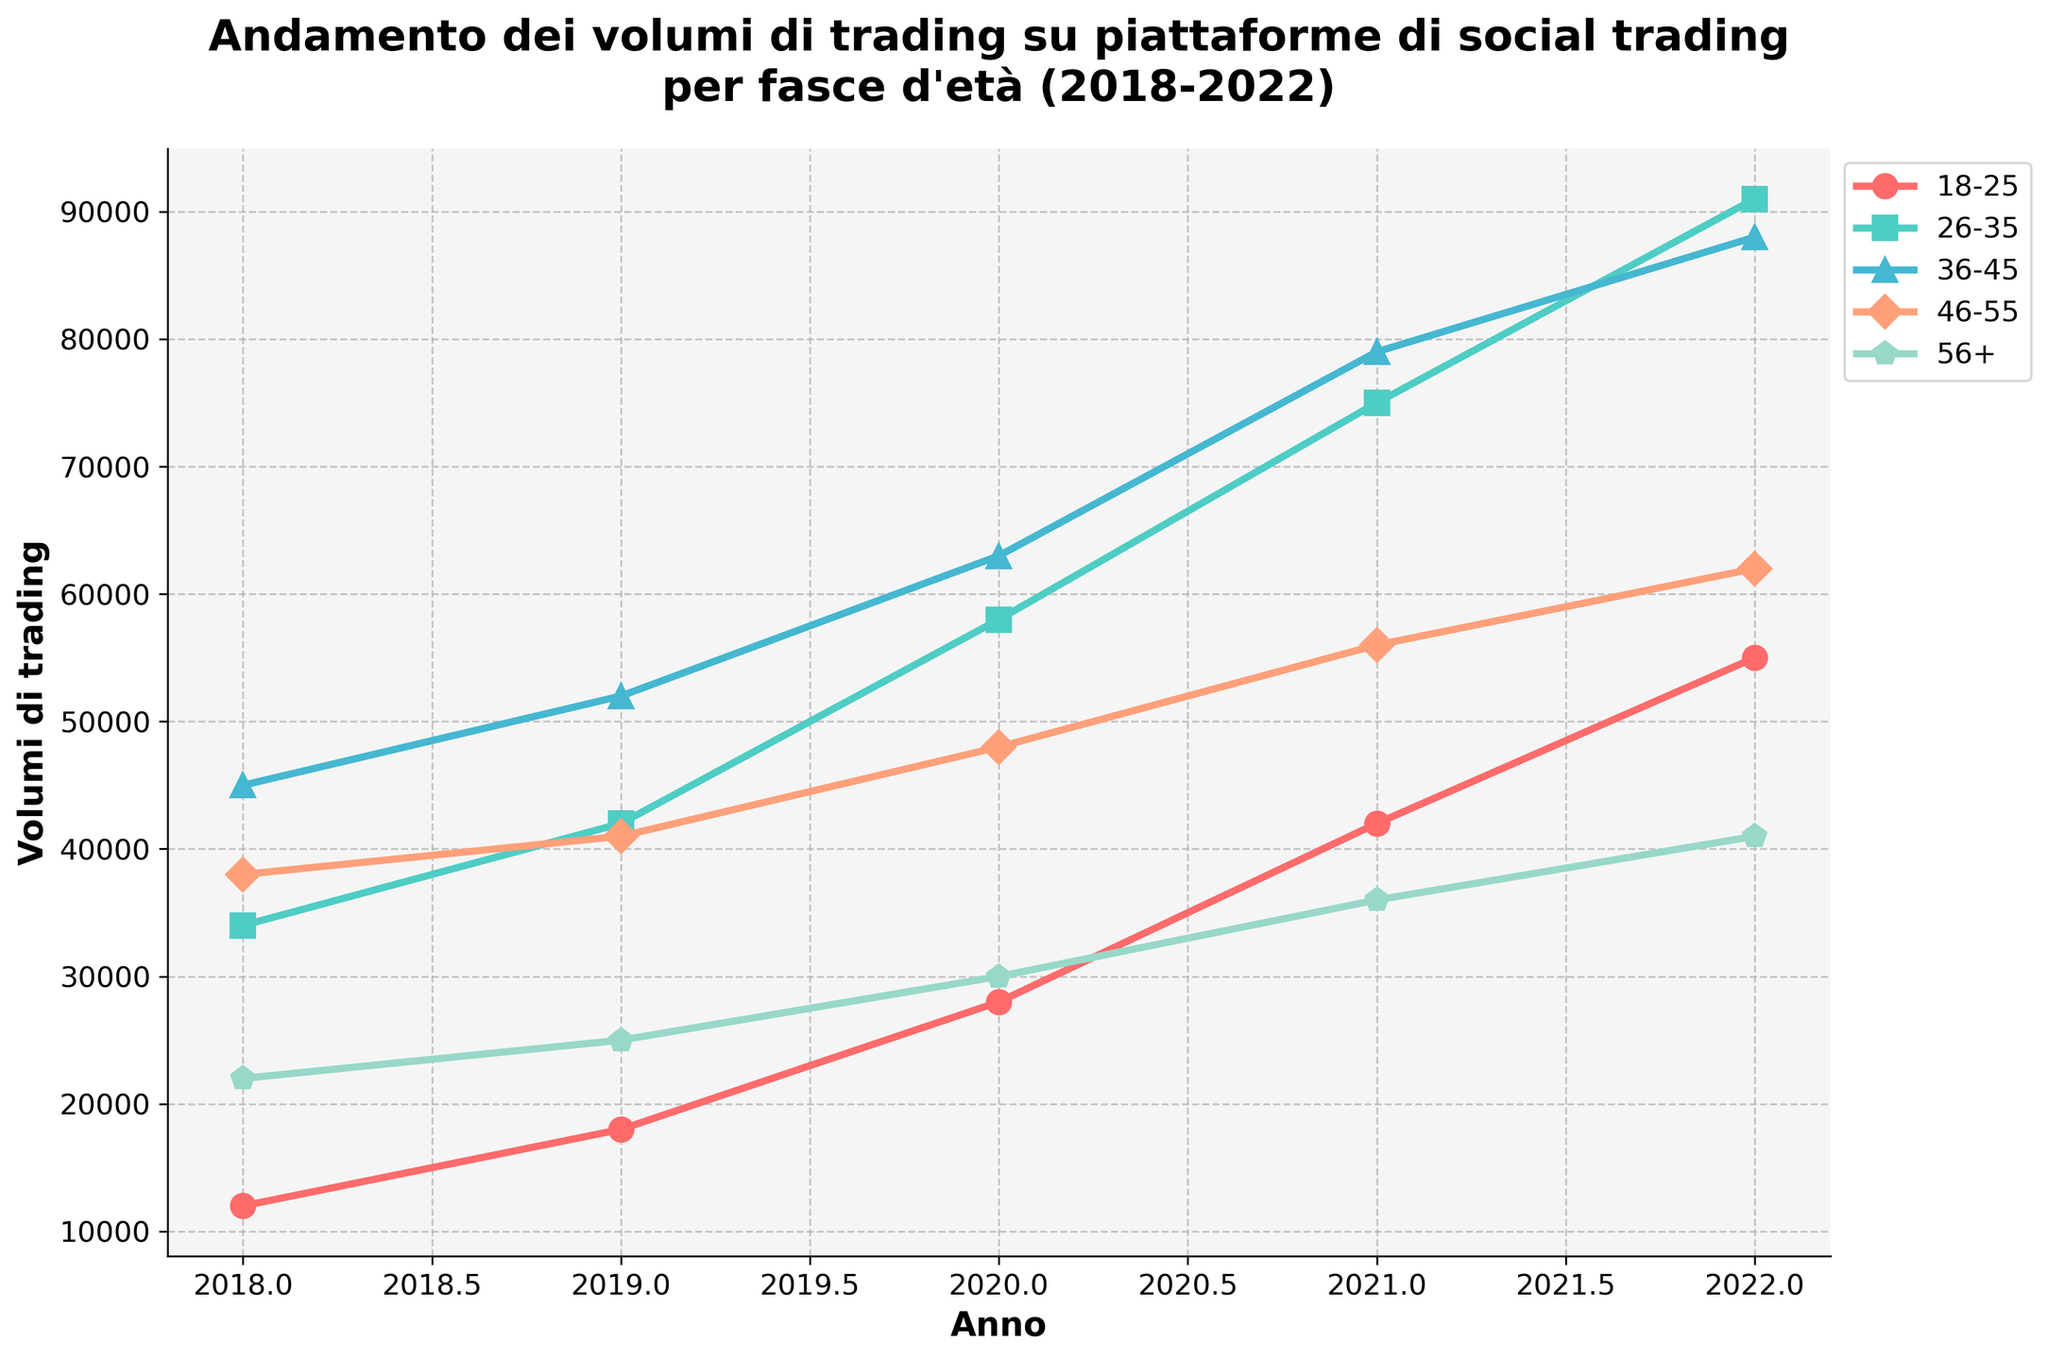What year saw the highest trading volume for the age group 26-35? Referring to the line chart, the trading volume for the age group 26-35 increases over the years. The peak is reached in the year 2022.
Answer: 2022 Which age group had the smallest increase in trading volume from 2018 to 2022? Calculate the difference in trading volumes for each age group between 2018 and 2022. The smallest increase is for the age group 56+ (41000 - 22000 = 19000).
Answer: 56+ How much more volume did the age group 36-45 have compared to 46-55 in 2020? The trading volume for the age group 36-45 in 2020 is 63000, and for 46-55 it is 48000. The difference is 63000 - 48000 = 15000.
Answer: 15000 What is the trend of trading volumes for the age group 18-25 from 2018 to 2022? Observing the chart, the trading volume for the age group 18-25 increases consistently from 2018 (12000) to 2022 (55000).
Answer: Increasing Which age group had consistently higher trading volumes than 46-55 across all years? Reviewing the trading volumes over the years, the age groups 26-35, 36-45, and 56+ had higher volumes than 46-55 in all years.
Answer: 26-35, 36-45, 56+ Did the trading volume for the age group 56+ ever surpass that of 46-55? Analyzing the trend lines, the trading volume for the age group 56+ is always below that of 46-55.
Answer: No What is the average annual trading volume for the age group 26-35 between 2018 and 2022? Sum the trading volumes from 2018 to 2022 (34000 + 42000 + 58000 + 75000 + 91000) = 300000, then divide by the number of years (300000 / 5).
Answer: 60000 In which year did the trading volume for the age group 36-45 see the largest annual increase? Calculate the annual increase for each year: 2018-2019 (52000 - 45000 = 7000), 2019-2020 (63000 - 52000 = 11000), 2020-2021 (79000 - 63000 = 16000), 2021-2022 (88000 - 79000 = 9000). The largest increase is from 2020 to 2021.
Answer: 2020-2021 